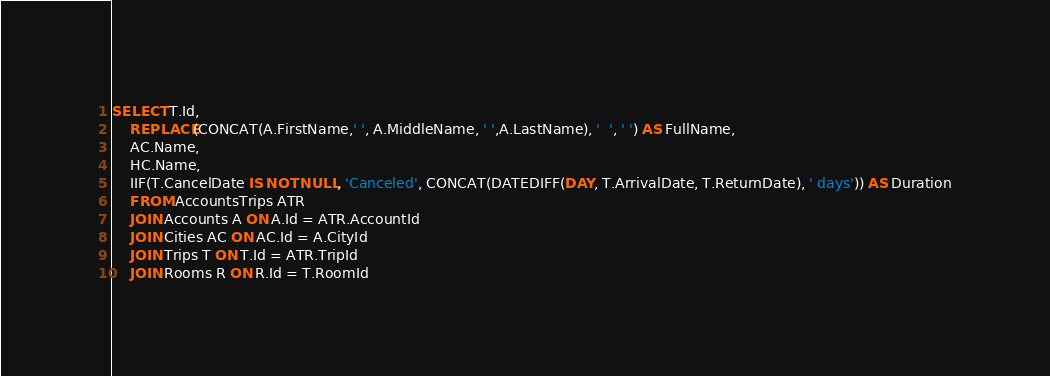<code> <loc_0><loc_0><loc_500><loc_500><_SQL_>SELECT T.Id,
	REPLACE(CONCAT(A.FirstName,' ', A.MiddleName, ' ',A.LastName), '  ', ' ') AS FullName,
	AC.Name,
	HC.Name,
	IIF(T.CancelDate IS NOT NULL, 'Canceled', CONCAT(DATEDIFF(DAY, T.ArrivalDate, T.ReturnDate), ' days')) AS Duration
	FROM AccountsTrips ATR
	JOIN Accounts A ON A.Id = ATR.AccountId
	JOIN Cities AC ON AC.Id = A.CityId
	JOIN Trips T ON T.Id = ATR.TripId
	JOIN Rooms R ON R.Id = T.RoomId</code> 